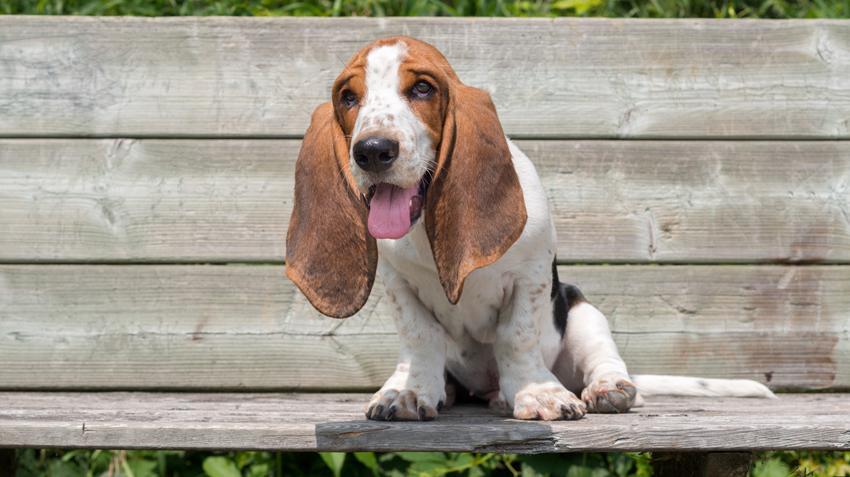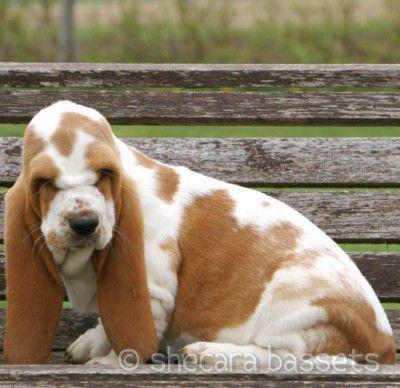The first image is the image on the left, the second image is the image on the right. Given the left and right images, does the statement "The right image shows one basset hound reclining on the ground, and the left image shows two hounds interacting." hold true? Answer yes or no. No. The first image is the image on the left, the second image is the image on the right. Evaluate the accuracy of this statement regarding the images: "There is exactly two dogs in the left image.". Is it true? Answer yes or no. No. 